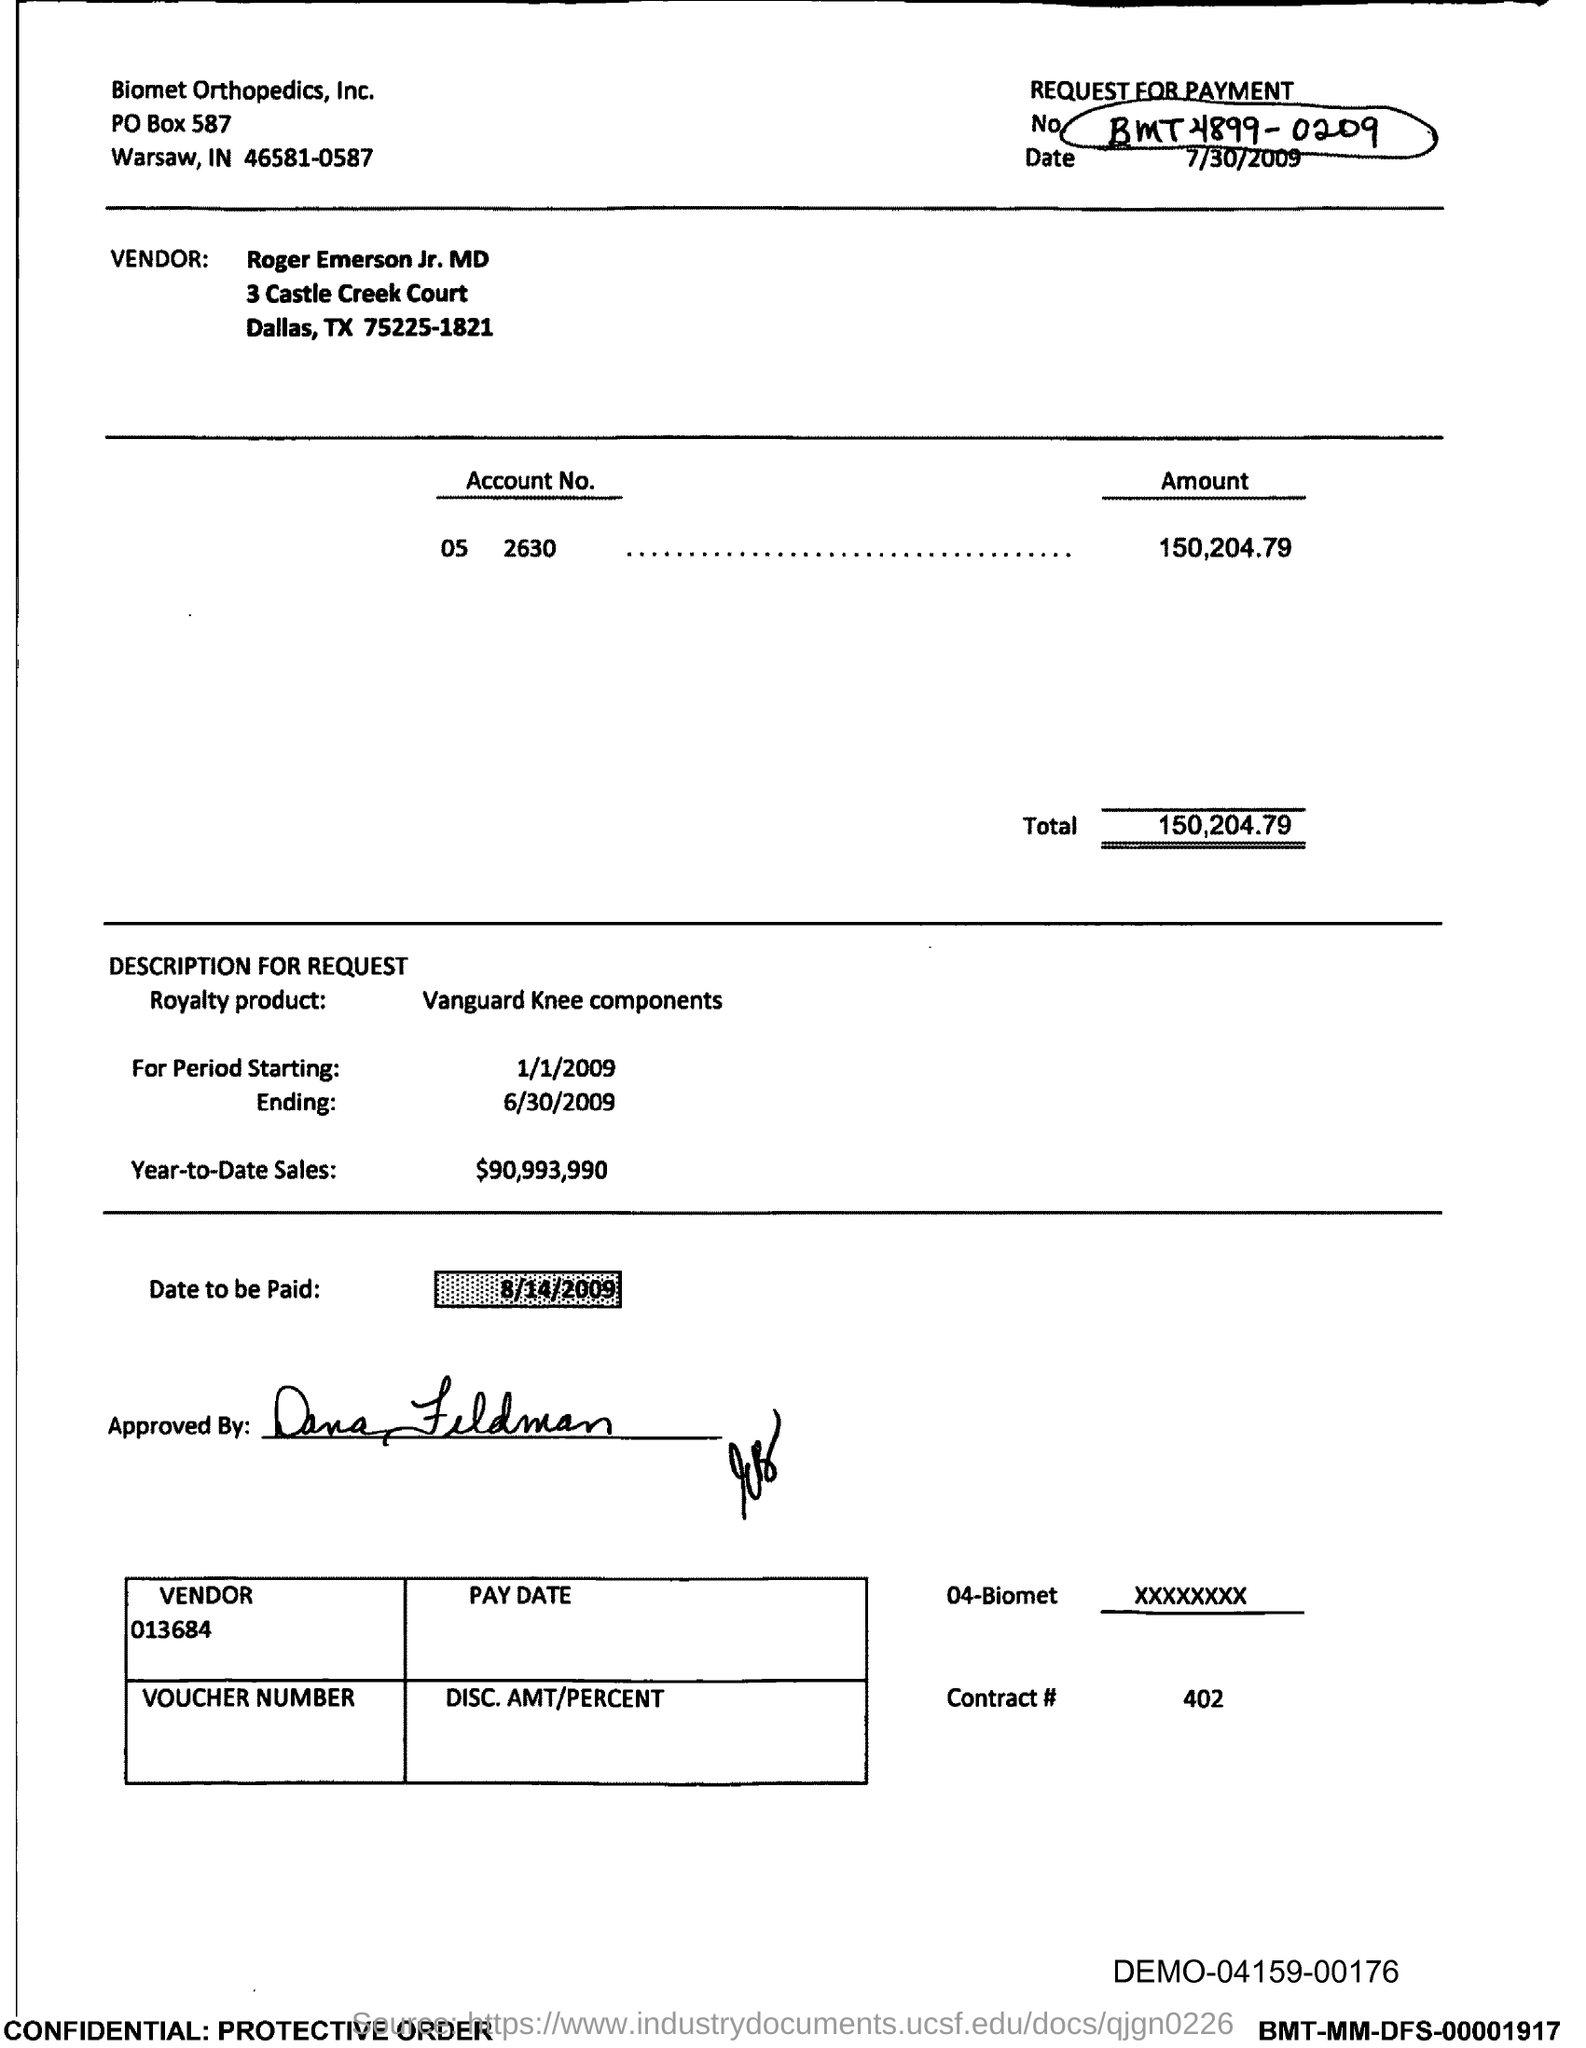What is the po box no. of biomet orthopedics, inc. ?
Offer a terse response. 587. In which state is biomet orthopedic, inc located?
Offer a terse response. IN. What is total ?
Your response must be concise. 150,204.79. What is name of royalty product ?
Provide a succinct answer. Vanguard Knee components. What is the year-to-date sales?
Offer a very short reply. $90,993,990. What is the date to be paid?
Offer a terse response. 8/14/2009. What is contract #?
Provide a short and direct response. 402. What is vendor number ?
Provide a succinct answer. 013684. 